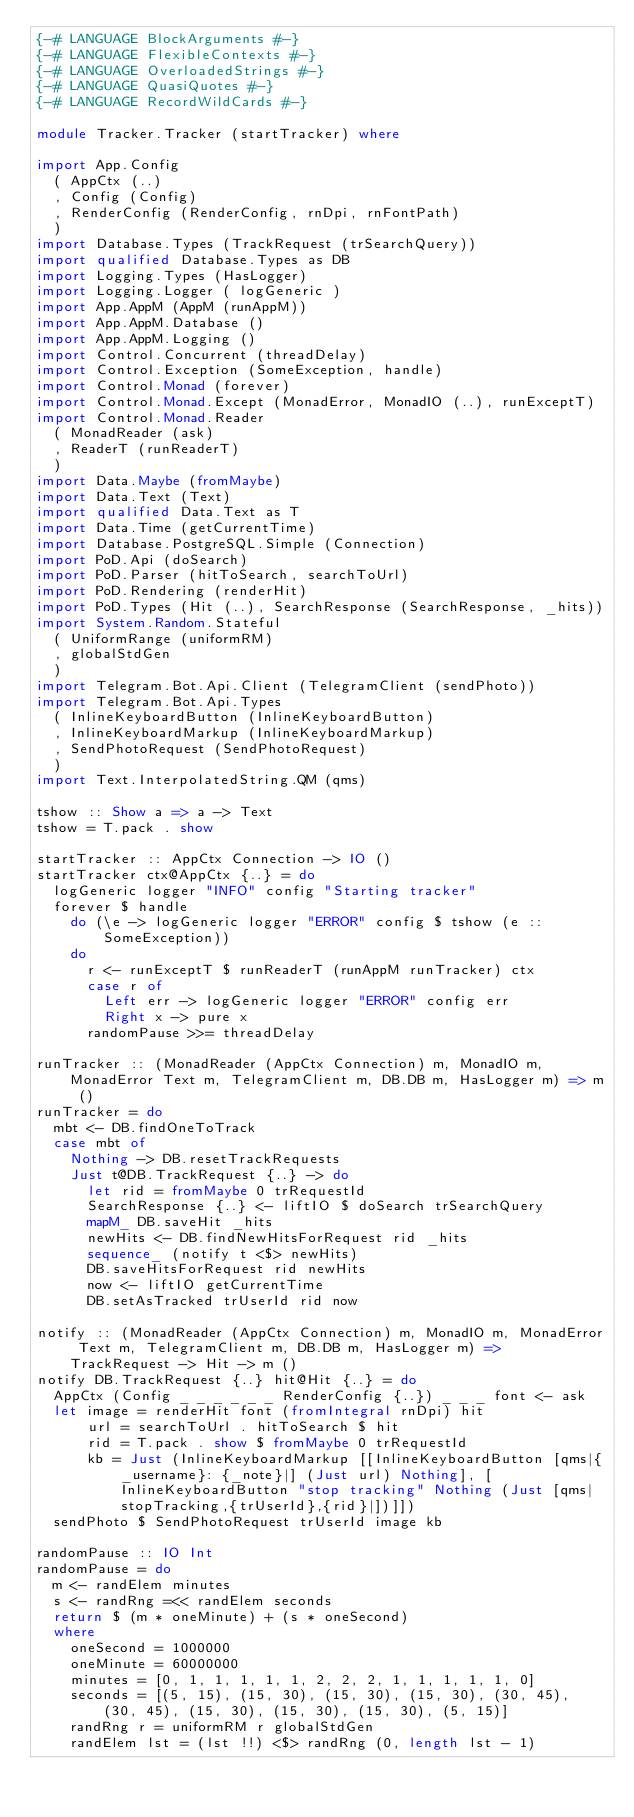Convert code to text. <code><loc_0><loc_0><loc_500><loc_500><_Haskell_>{-# LANGUAGE BlockArguments #-}
{-# LANGUAGE FlexibleContexts #-}
{-# LANGUAGE OverloadedStrings #-}
{-# LANGUAGE QuasiQuotes #-}
{-# LANGUAGE RecordWildCards #-}

module Tracker.Tracker (startTracker) where

import App.Config
  ( AppCtx (..)
  , Config (Config)
  , RenderConfig (RenderConfig, rnDpi, rnFontPath)
  )
import Database.Types (TrackRequest (trSearchQuery))
import qualified Database.Types as DB
import Logging.Types (HasLogger)
import Logging.Logger ( logGeneric )
import App.AppM (AppM (runAppM))
import App.AppM.Database ()
import App.AppM.Logging ()
import Control.Concurrent (threadDelay)
import Control.Exception (SomeException, handle)
import Control.Monad (forever)
import Control.Monad.Except (MonadError, MonadIO (..), runExceptT)
import Control.Monad.Reader
  ( MonadReader (ask)
  , ReaderT (runReaderT)
  )
import Data.Maybe (fromMaybe)
import Data.Text (Text)
import qualified Data.Text as T
import Data.Time (getCurrentTime)
import Database.PostgreSQL.Simple (Connection)
import PoD.Api (doSearch)
import PoD.Parser (hitToSearch, searchToUrl)
import PoD.Rendering (renderHit)
import PoD.Types (Hit (..), SearchResponse (SearchResponse, _hits))
import System.Random.Stateful
  ( UniformRange (uniformRM)
  , globalStdGen
  )
import Telegram.Bot.Api.Client (TelegramClient (sendPhoto))
import Telegram.Bot.Api.Types
  ( InlineKeyboardButton (InlineKeyboardButton)
  , InlineKeyboardMarkup (InlineKeyboardMarkup)
  , SendPhotoRequest (SendPhotoRequest)
  )
import Text.InterpolatedString.QM (qms)

tshow :: Show a => a -> Text
tshow = T.pack . show

startTracker :: AppCtx Connection -> IO ()
startTracker ctx@AppCtx {..} = do
  logGeneric logger "INFO" config "Starting tracker"
  forever $ handle 
    do (\e -> logGeneric logger "ERROR" config $ tshow (e :: SomeException)) 
    do
      r <- runExceptT $ runReaderT (runAppM runTracker) ctx
      case r of
        Left err -> logGeneric logger "ERROR" config err
        Right x -> pure x
      randomPause >>= threadDelay

runTracker :: (MonadReader (AppCtx Connection) m, MonadIO m, MonadError Text m, TelegramClient m, DB.DB m, HasLogger m) => m ()
runTracker = do
  mbt <- DB.findOneToTrack
  case mbt of
    Nothing -> DB.resetTrackRequests
    Just t@DB.TrackRequest {..} -> do
      let rid = fromMaybe 0 trRequestId
      SearchResponse {..} <- liftIO $ doSearch trSearchQuery
      mapM_ DB.saveHit _hits
      newHits <- DB.findNewHitsForRequest rid _hits
      sequence_ (notify t <$> newHits)
      DB.saveHitsForRequest rid newHits
      now <- liftIO getCurrentTime
      DB.setAsTracked trUserId rid now

notify :: (MonadReader (AppCtx Connection) m, MonadIO m, MonadError Text m, TelegramClient m, DB.DB m, HasLogger m) => TrackRequest -> Hit -> m ()
notify DB.TrackRequest {..} hit@Hit {..} = do
  AppCtx (Config _ _ _ _ _ _ RenderConfig {..}) _ _ _ font <- ask
  let image = renderHit font (fromIntegral rnDpi) hit
      url = searchToUrl . hitToSearch $ hit
      rid = T.pack . show $ fromMaybe 0 trRequestId
      kb = Just (InlineKeyboardMarkup [[InlineKeyboardButton [qms|{_username}: {_note}|] (Just url) Nothing], [InlineKeyboardButton "stop tracking" Nothing (Just [qms|stopTracking,{trUserId},{rid}|])]])
  sendPhoto $ SendPhotoRequest trUserId image kb

randomPause :: IO Int
randomPause = do
  m <- randElem minutes
  s <- randRng =<< randElem seconds
  return $ (m * oneMinute) + (s * oneSecond)
  where
    oneSecond = 1000000
    oneMinute = 60000000
    minutes = [0, 1, 1, 1, 1, 1, 2, 2, 2, 1, 1, 1, 1, 1, 0]
    seconds = [(5, 15), (15, 30), (15, 30), (15, 30), (30, 45), (30, 45), (15, 30), (15, 30), (15, 30), (5, 15)]
    randRng r = uniformRM r globalStdGen
    randElem lst = (lst !!) <$> randRng (0, length lst - 1)
</code> 